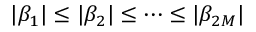Convert formula to latex. <formula><loc_0><loc_0><loc_500><loc_500>| \beta _ { 1 } | \leq | \beta _ { 2 } | \leq \cdots \leq | \beta _ { 2 M } |</formula> 